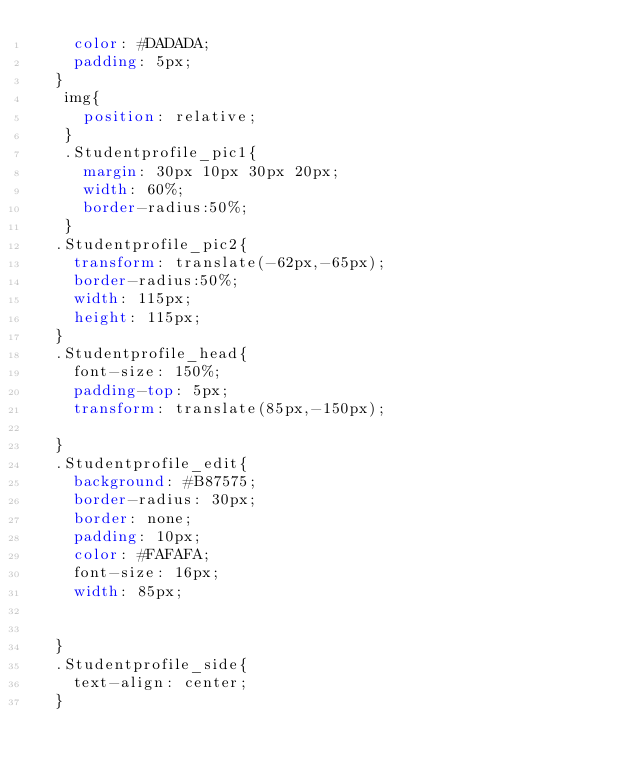Convert code to text. <code><loc_0><loc_0><loc_500><loc_500><_CSS_>    color: #DADADA;
    padding: 5px;
  }
   img{  
     position: relative;
   }
   .Studentprofile_pic1{
     margin: 30px 10px 30px 20px;
     width: 60%;
     border-radius:50%;
   }
  .Studentprofile_pic2{
    transform: translate(-62px,-65px);
    border-radius:50%;
    width: 115px;
    height: 115px;
  }
  .Studentprofile_head{
    font-size: 150%;
    padding-top: 5px;
    transform: translate(85px,-150px);
  
  }
  .Studentprofile_edit{
    background: #B87575;
    border-radius: 30px; 
    border: none;
    padding: 10px;
    color: #FAFAFA;
    font-size: 16px;
    width: 85px;
    
  
  }
  .Studentprofile_side{
    text-align: center;
  }</code> 